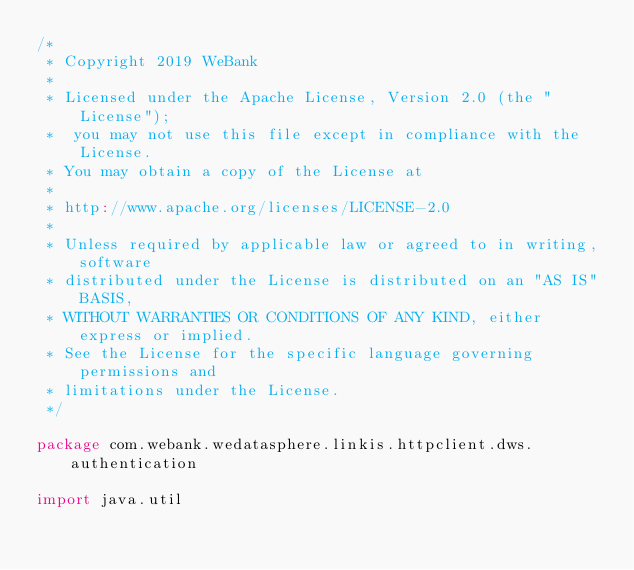Convert code to text. <code><loc_0><loc_0><loc_500><loc_500><_Scala_>/*
 * Copyright 2019 WeBank
 *
 * Licensed under the Apache License, Version 2.0 (the "License");
 *  you may not use this file except in compliance with the License.
 * You may obtain a copy of the License at
 *
 * http://www.apache.org/licenses/LICENSE-2.0
 *
 * Unless required by applicable law or agreed to in writing, software
 * distributed under the License is distributed on an "AS IS" BASIS,
 * WITHOUT WARRANTIES OR CONDITIONS OF ANY KIND, either express or implied.
 * See the License for the specific language governing permissions and
 * limitations under the License.
 */

package com.webank.wedatasphere.linkis.httpclient.dws.authentication

import java.util
</code> 